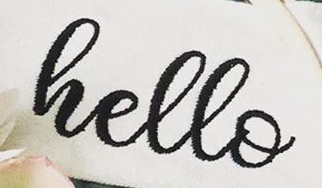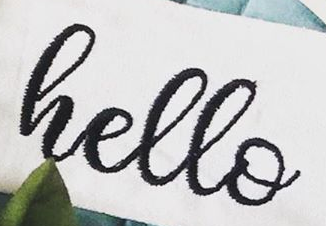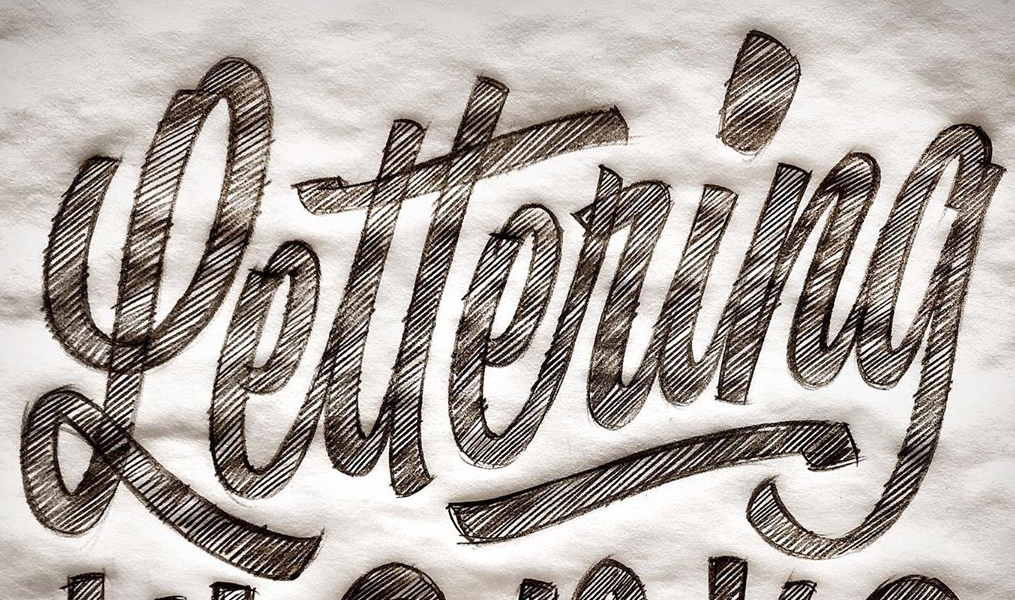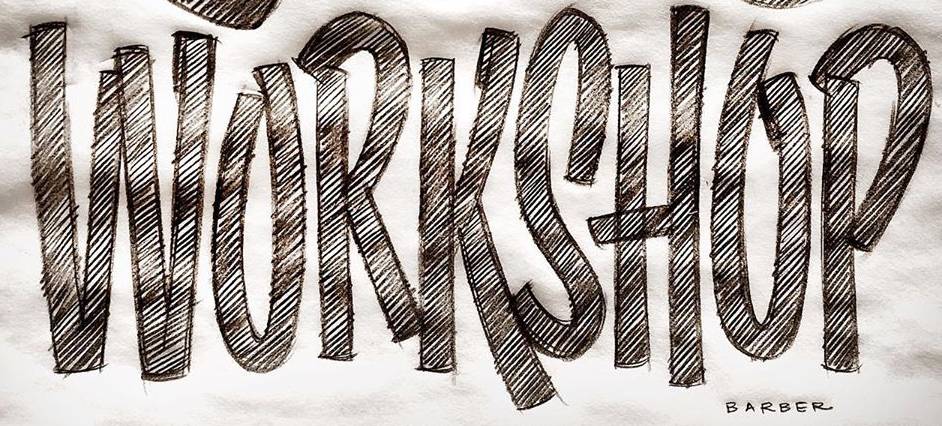Read the text content from these images in order, separated by a semicolon. hello; hello; Lettering; WORKSHOP 